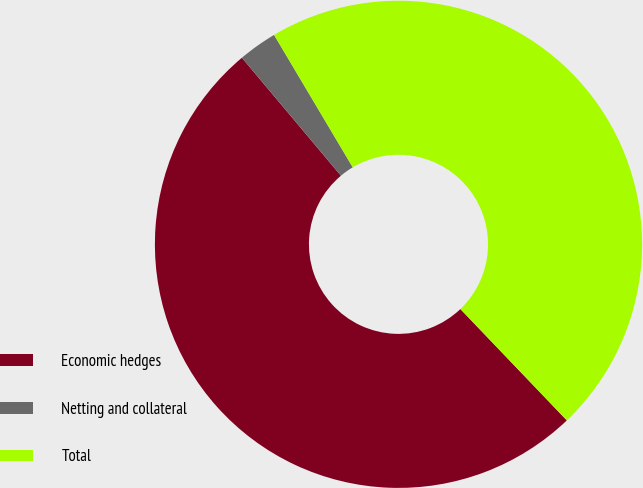Convert chart. <chart><loc_0><loc_0><loc_500><loc_500><pie_chart><fcel>Economic hedges<fcel>Netting and collateral<fcel>Total<nl><fcel>51.03%<fcel>2.58%<fcel>46.39%<nl></chart> 